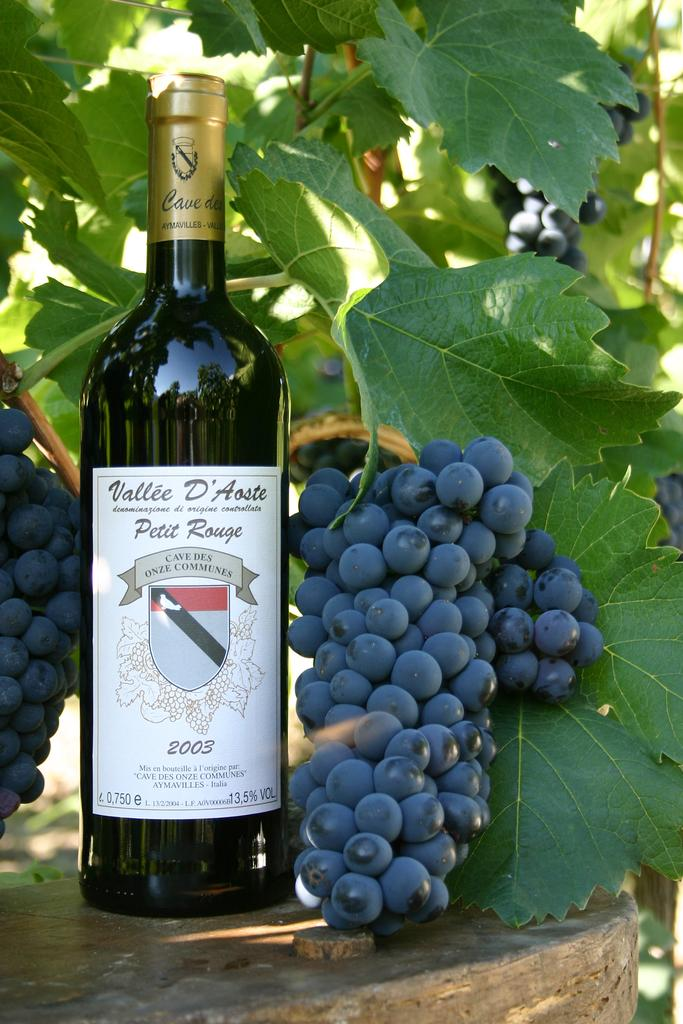What type of fruit can be seen in the image? There are grapes in the image. What is the grapes likely to be used for? The grapes are likely to be used for making wine, as there is a wine bottle in the image. What other elements can be seen in the image? There are leaves visible in the image. What type of produce is visible in the image? There is no produce other than the grapes visible in the image. Can you describe the flock of birds in the image? There are no birds or flocks present in the image. 